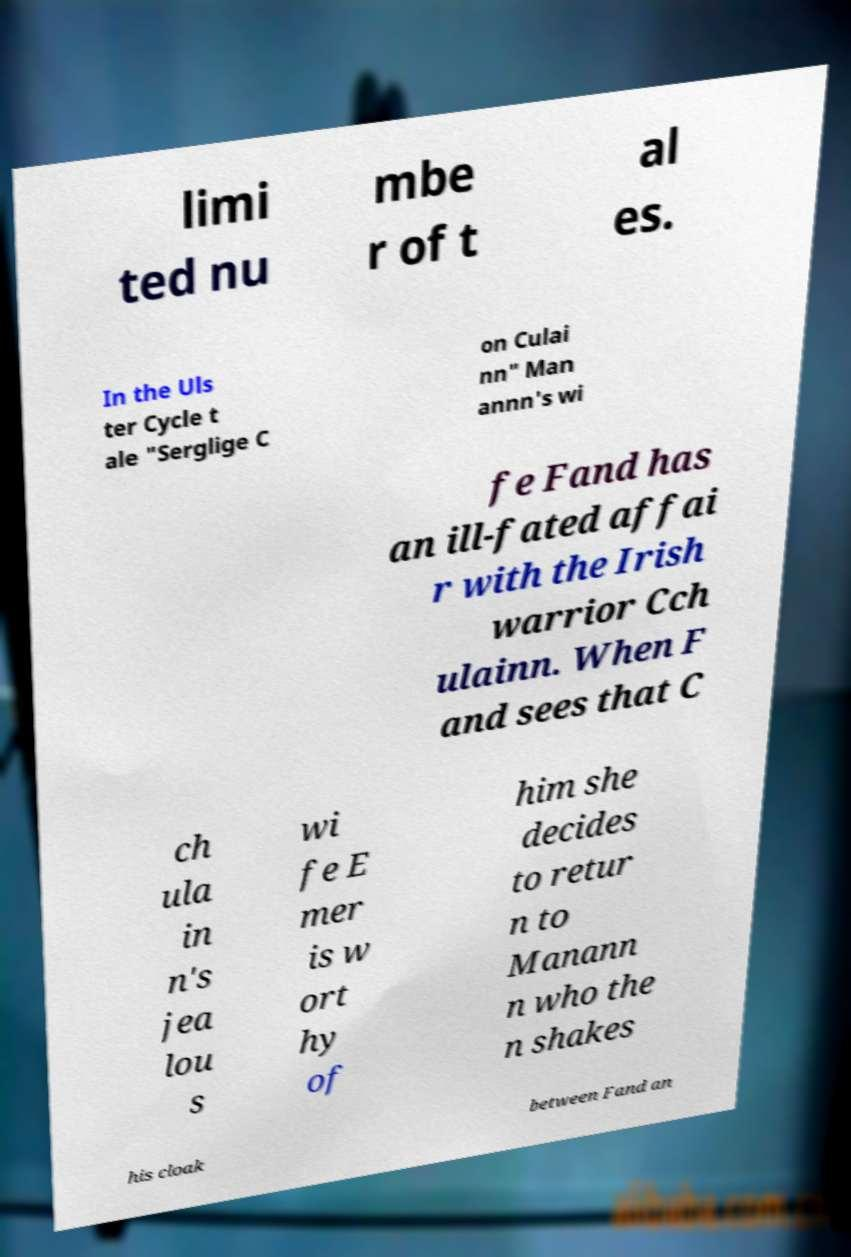There's text embedded in this image that I need extracted. Can you transcribe it verbatim? limi ted nu mbe r of t al es. In the Uls ter Cycle t ale "Serglige C on Culai nn" Man annn's wi fe Fand has an ill-fated affai r with the Irish warrior Cch ulainn. When F and sees that C ch ula in n's jea lou s wi fe E mer is w ort hy of him she decides to retur n to Manann n who the n shakes his cloak between Fand an 